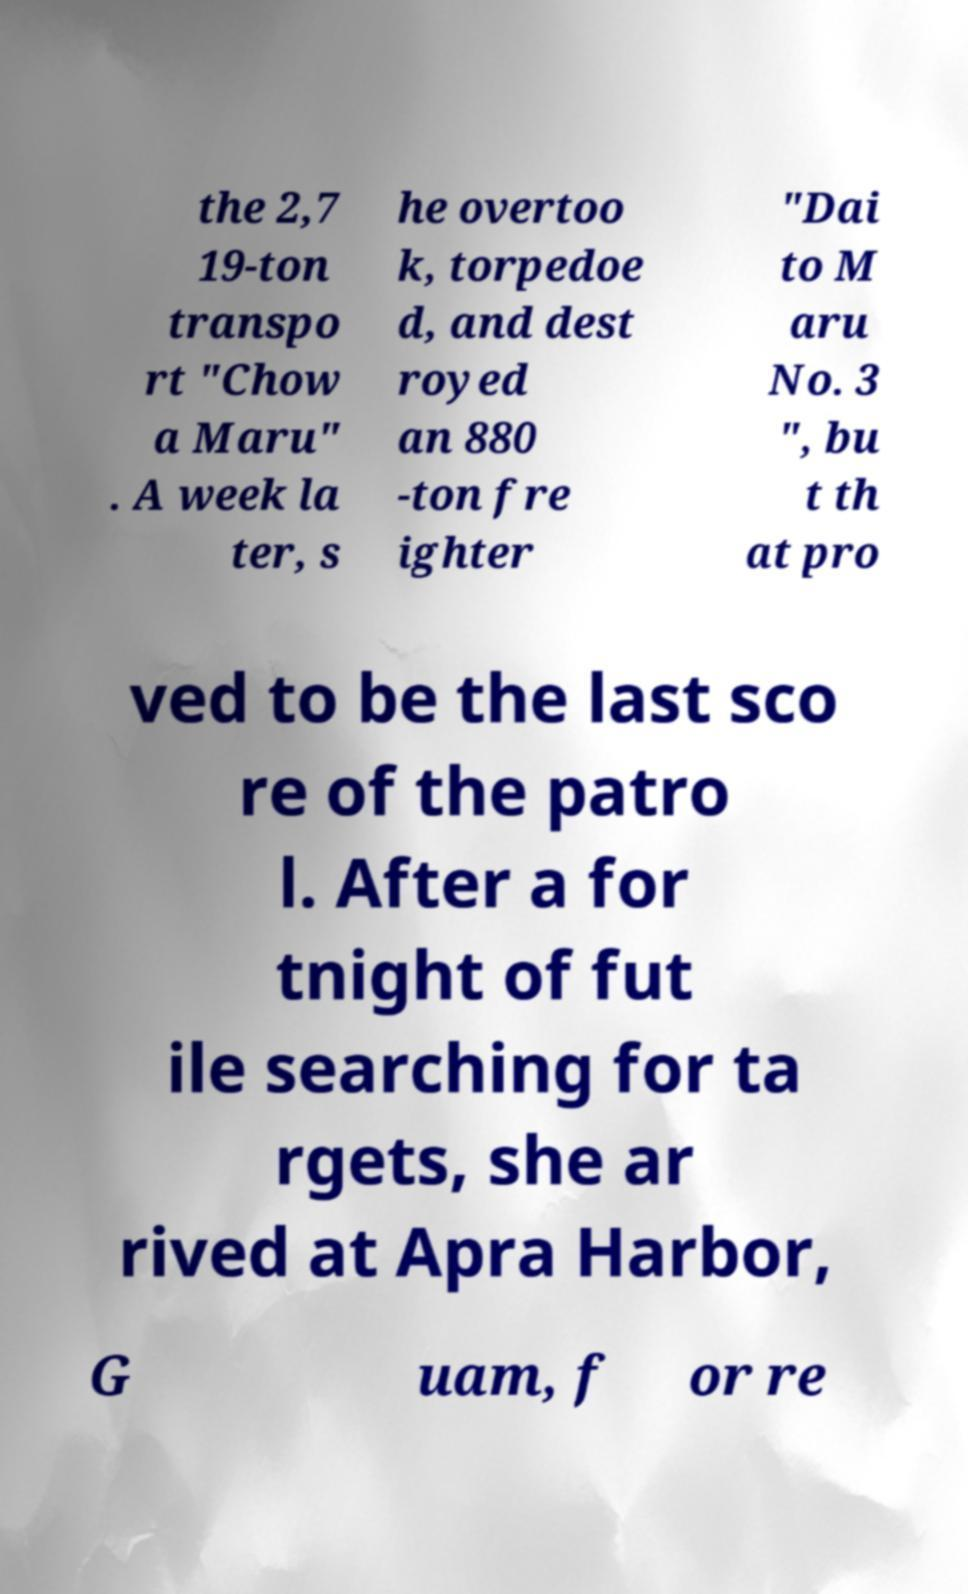For documentation purposes, I need the text within this image transcribed. Could you provide that? the 2,7 19-ton transpo rt "Chow a Maru" . A week la ter, s he overtoo k, torpedoe d, and dest royed an 880 -ton fre ighter "Dai to M aru No. 3 ", bu t th at pro ved to be the last sco re of the patro l. After a for tnight of fut ile searching for ta rgets, she ar rived at Apra Harbor, G uam, f or re 